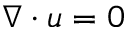Convert formula to latex. <formula><loc_0><loc_0><loc_500><loc_500>\nabla \cdot u = 0</formula> 